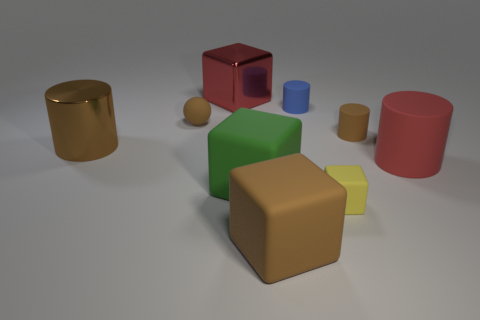Subtract 1 cubes. How many cubes are left? 3 Add 1 brown blocks. How many objects exist? 10 Subtract all cylinders. How many objects are left? 5 Subtract all big green cubes. Subtract all big blocks. How many objects are left? 5 Add 9 big green blocks. How many big green blocks are left? 10 Add 6 yellow shiny things. How many yellow shiny things exist? 6 Subtract 0 green cylinders. How many objects are left? 9 